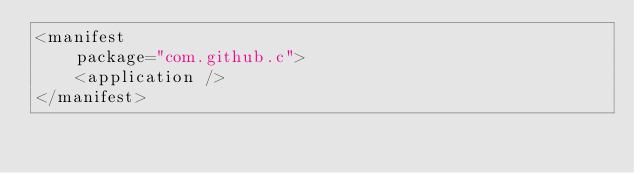<code> <loc_0><loc_0><loc_500><loc_500><_XML_><manifest
    package="com.github.c">
    <application />
</manifest>
</code> 